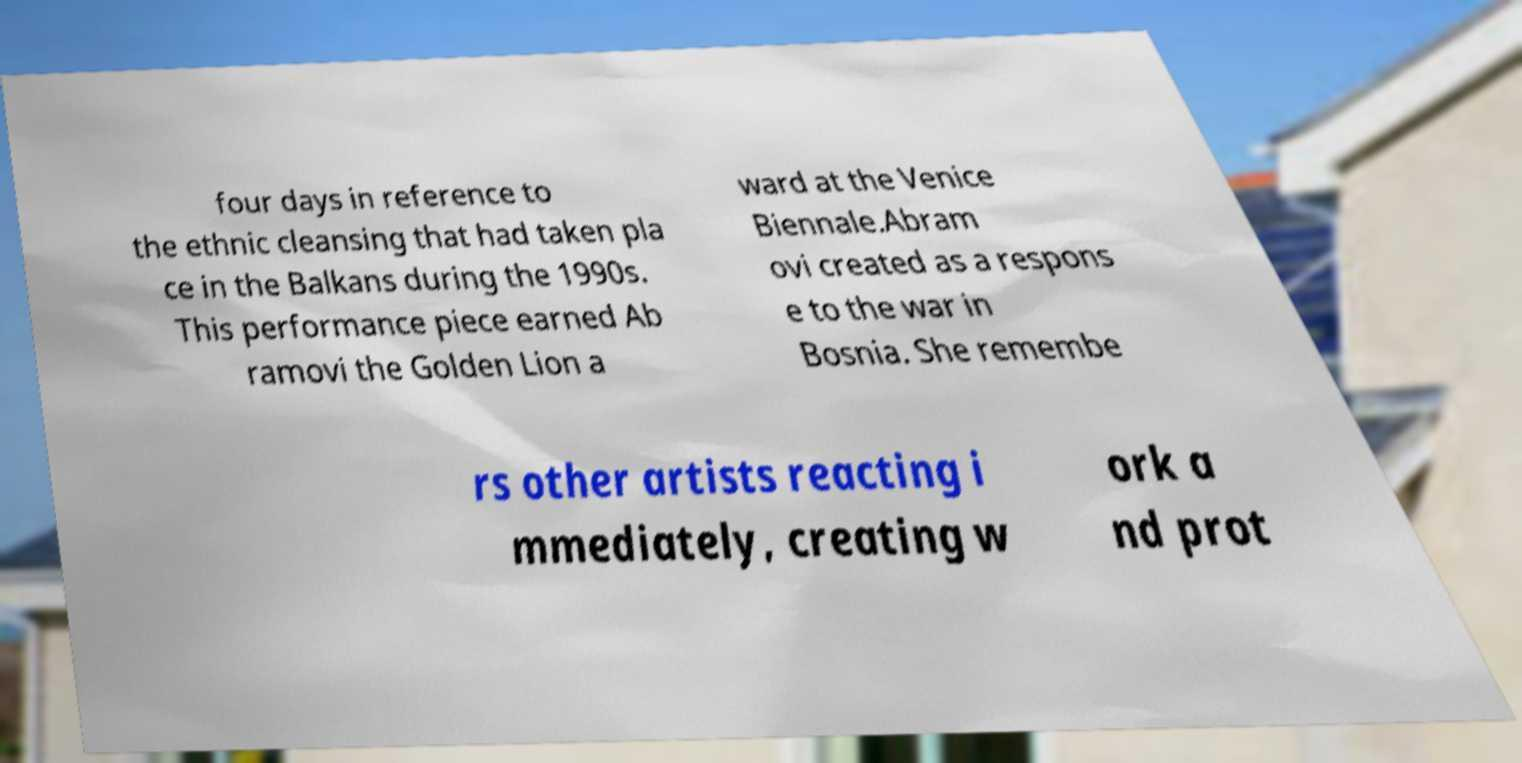Can you read and provide the text displayed in the image?This photo seems to have some interesting text. Can you extract and type it out for me? four days in reference to the ethnic cleansing that had taken pla ce in the Balkans during the 1990s. This performance piece earned Ab ramovi the Golden Lion a ward at the Venice Biennale.Abram ovi created as a respons e to the war in Bosnia. She remembe rs other artists reacting i mmediately, creating w ork a nd prot 